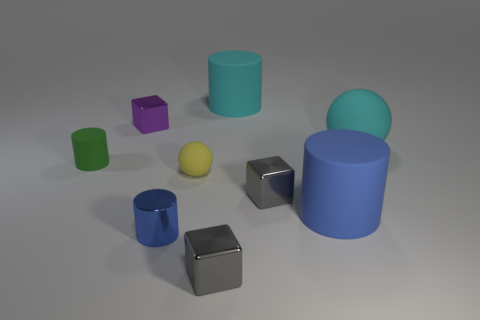Subtract all balls. How many objects are left? 7 Add 1 big blue cylinders. How many big blue cylinders exist? 2 Subtract 1 cyan cylinders. How many objects are left? 8 Subtract all gray cubes. Subtract all yellow matte spheres. How many objects are left? 6 Add 7 small green rubber cylinders. How many small green rubber cylinders are left? 8 